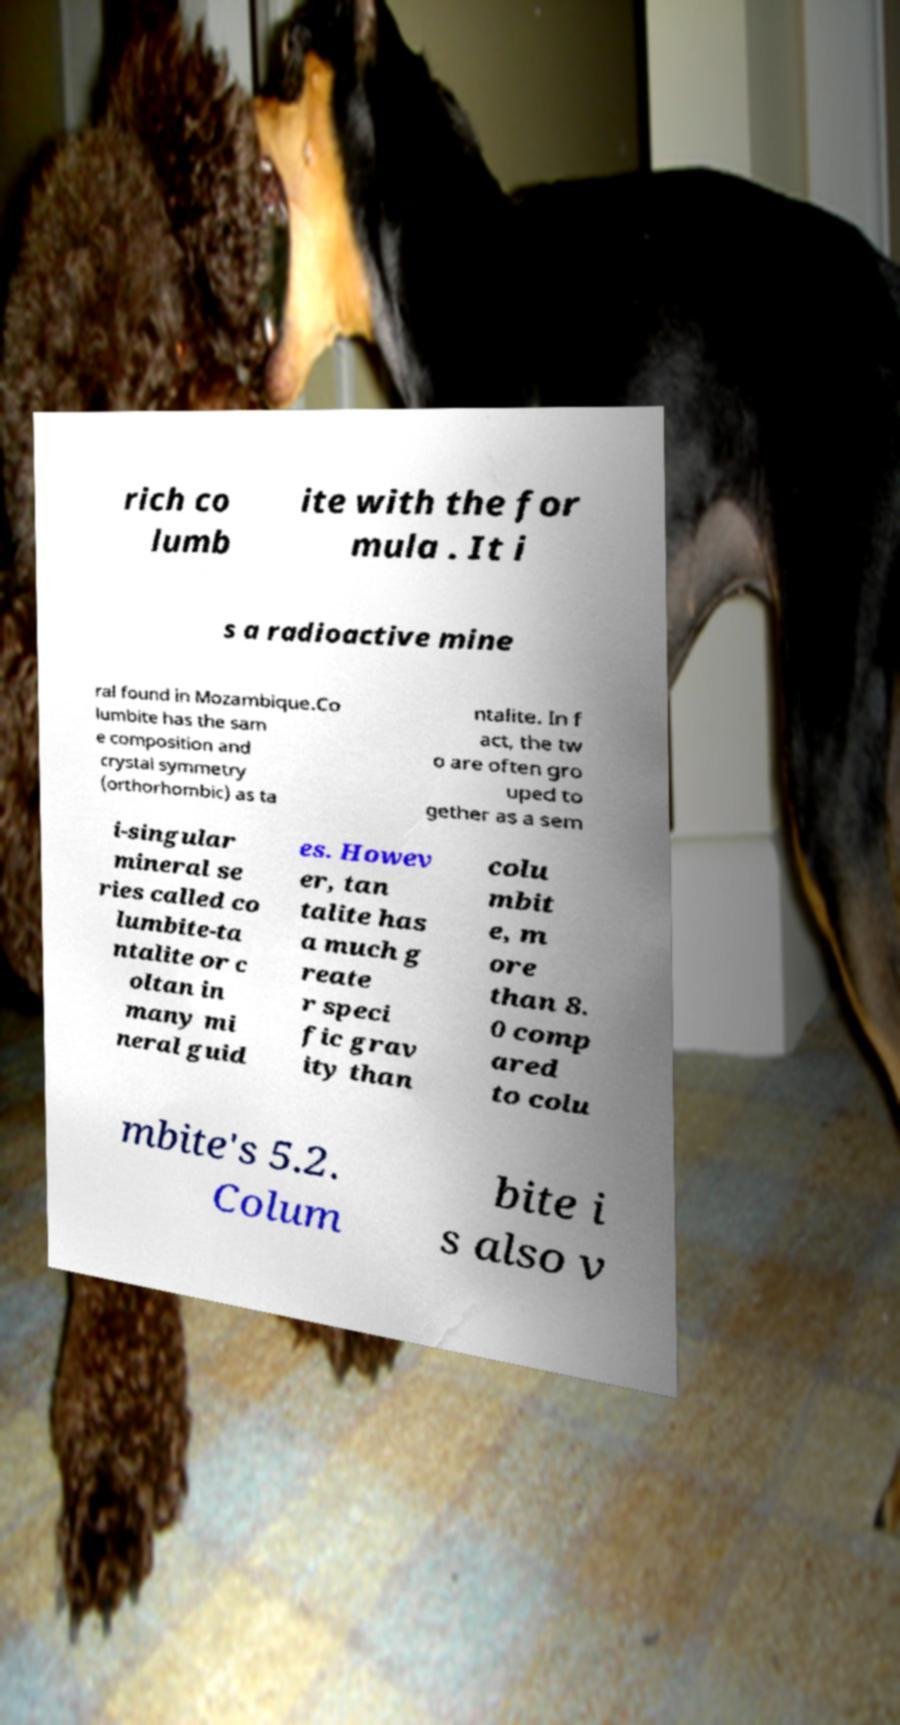Could you extract and type out the text from this image? rich co lumb ite with the for mula . It i s a radioactive mine ral found in Mozambique.Co lumbite has the sam e composition and crystal symmetry (orthorhombic) as ta ntalite. In f act, the tw o are often gro uped to gether as a sem i-singular mineral se ries called co lumbite-ta ntalite or c oltan in many mi neral guid es. Howev er, tan talite has a much g reate r speci fic grav ity than colu mbit e, m ore than 8. 0 comp ared to colu mbite's 5.2. Colum bite i s also v 